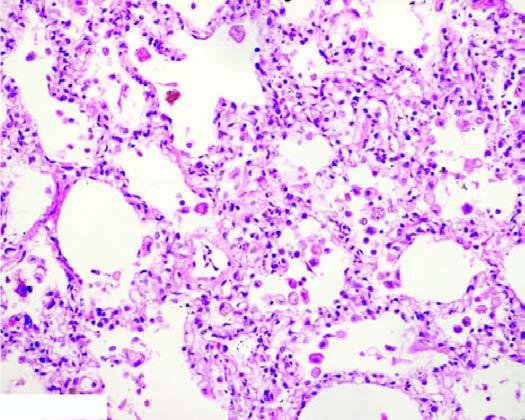do the alveolar lumina contain heart failure cells alveolar macrophages containing haemosiderin pigment?
Answer the question using a single word or phrase. Yes 